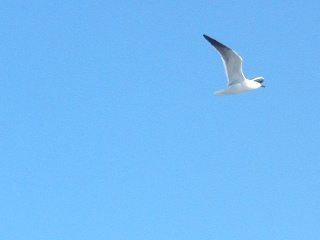Imagine a conversation between this bird and another bird it might meet. Bird A: "What a splendid day for a flight! The sky is perfect!"
Bird B: "Absolutely, the blue stretches endlessly. Let's see who can soar higher!"
Bird A: "You're on! But let's catch a fish for lunch first."
Bird B: "Great idea, I know a spot by the cliffs where the view is breathtaking." 